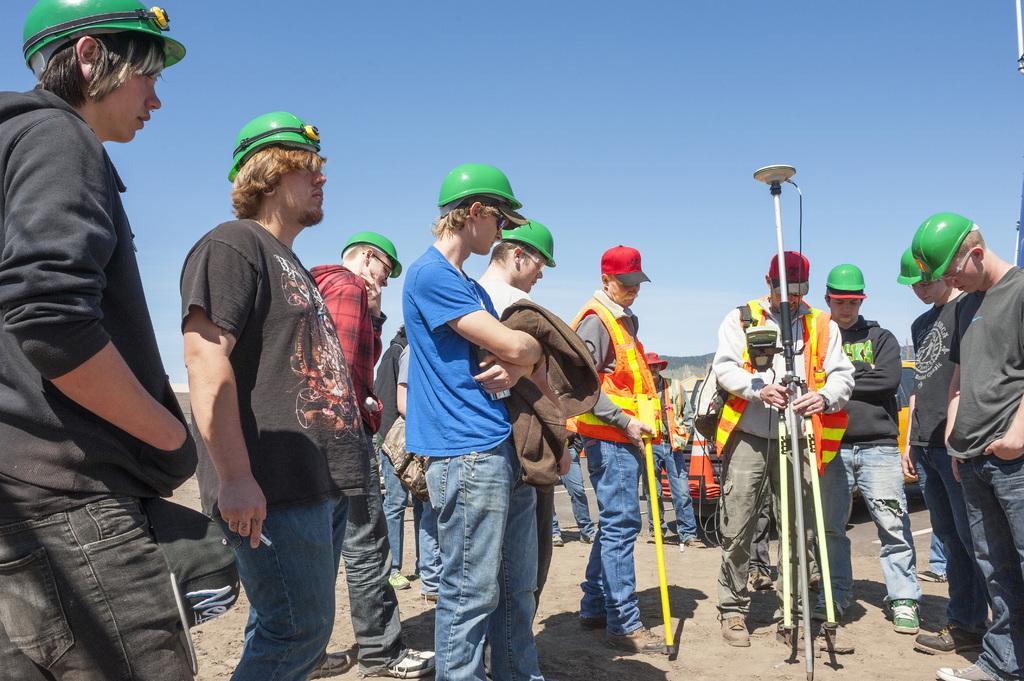In one or two sentences, can you explain what this image depicts? In this image at the top there is the sky, in the foreground there are few peoples, one person holding a stand, behind them there is a vehicle. 